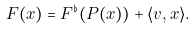<formula> <loc_0><loc_0><loc_500><loc_500>F ( x ) = F ^ { \flat } ( P ( x ) ) + \langle v , x \rangle .</formula> 